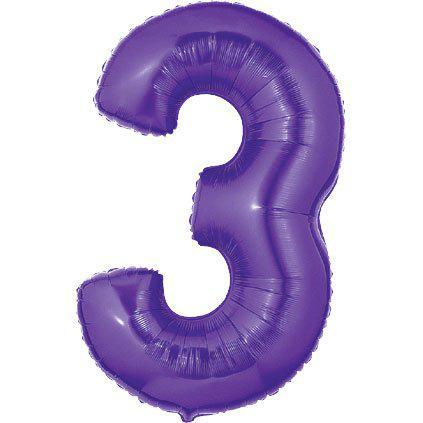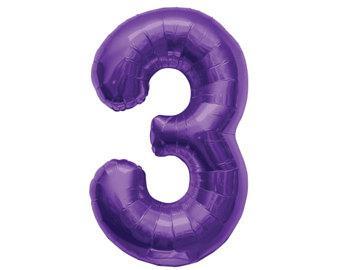The first image is the image on the left, the second image is the image on the right. Given the left and right images, does the statement "All the number three balloons are blue." hold true? Answer yes or no. No. The first image is the image on the left, the second image is the image on the right. Assess this claim about the two images: "Each image contains exactly one purple item shaped like the number three.". Correct or not? Answer yes or no. Yes. 